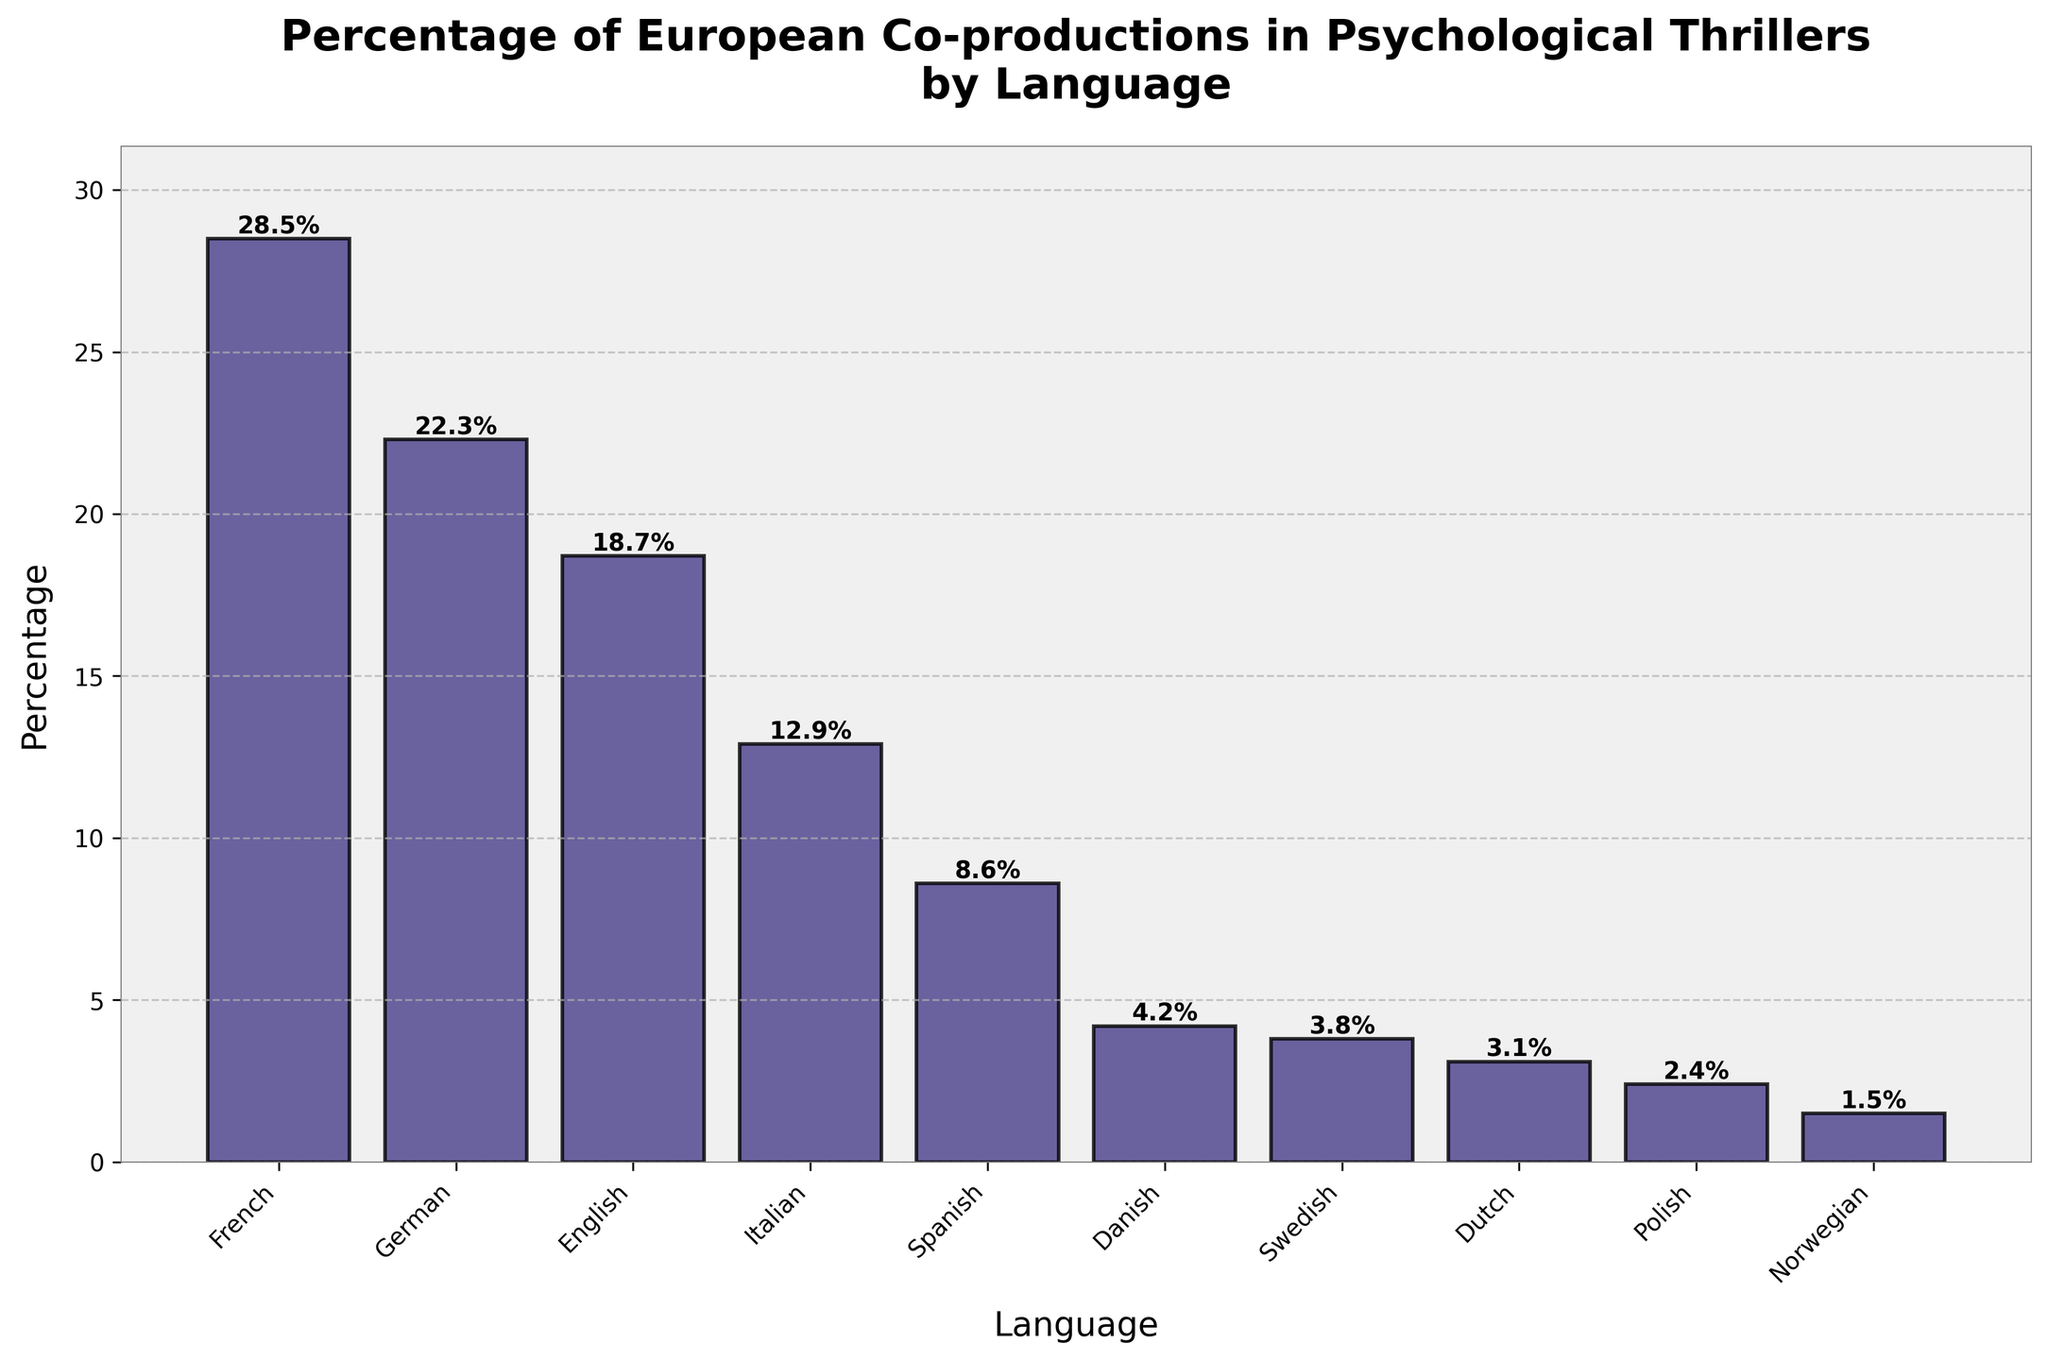What language has the highest percentage of European co-productions in psychological thrillers? The bar chart indicates the percentage of European co-productions in psychological thrillers by language. The bar labeled "French" is the tallest, indicating that French has the highest percentage.
Answer: French What is the difference in percentage between French and German co-productions in psychological thrillers? According to the bar chart, French has 28.5% and German has 22.3%. The difference is found by subtracting German's percentage from French's percentage: 28.5% - 22.3% = 6.2%.
Answer: 6.2% Which languages have a percentage of co-productions less than 10%? The bars corresponding to Spanish, Danish, Swedish, Dutch, Polish, and Norwegian all have heights below the 10% mark.
Answer: Spanish, Danish, Swedish, Dutch, Polish, Norwegian What is the average percentage of co-productions among French, German, and English languages? To find the average, add the percentages of the three languages and divide by 3: (28.5% + 22.3% + 18.7%) / 3 = 69.5% / 3 = 23.17%.
Answer: 23.17% Which language has the lowest percentage of European co-productions in psychological thrillers? The bar chart shows that the bar labeled "Norwegian" is the shortest, which means Norwegian has the lowest percentage, at 1.5%.
Answer: Norwegian How much higher is the percentage of Italian co-productions compared to Danish co-productions? The percentage for Italian is 12.9%, and for Danish, it is 4.2%. The difference is 12.9% - 4.2% = 8.7%.
Answer: 8.7% What are the combined percentages of German, Italian, and Spanish co-productions? Adding the percentages for German (22.3%), Italian (12.9%), and Spanish (8.6%), we get 22.3% + 12.9% + 8.6% = 43.8%.
Answer: 43.8% Among the listed languages, which have percentages greater than English for co-productions? From the bar chart, French (28.5%) and German (22.3%) both have percentages higher than English (18.7%).
Answer: French, German What is the total percentage covered by the top three languages in terms of co-productions? Adding the percentages of French (28.5%), German (22.3%), and English (18.7%), we get 28.5% + 22.3% + 18.7% = 69.5%.
Answer: 69.5% If you only consider the Scandinavian languages (Danish, Swedish, Norwegian), what is their average percentage of co-productions? The percentages for the Scandinavian languages are Danish (4.2%), Swedish (3.8%), and Norwegian (1.5%). The average is calculated as (4.2% + 3.8% + 1.5%) / 3 = 9.5% / 3 = 3.17%.
Answer: 3.17% 